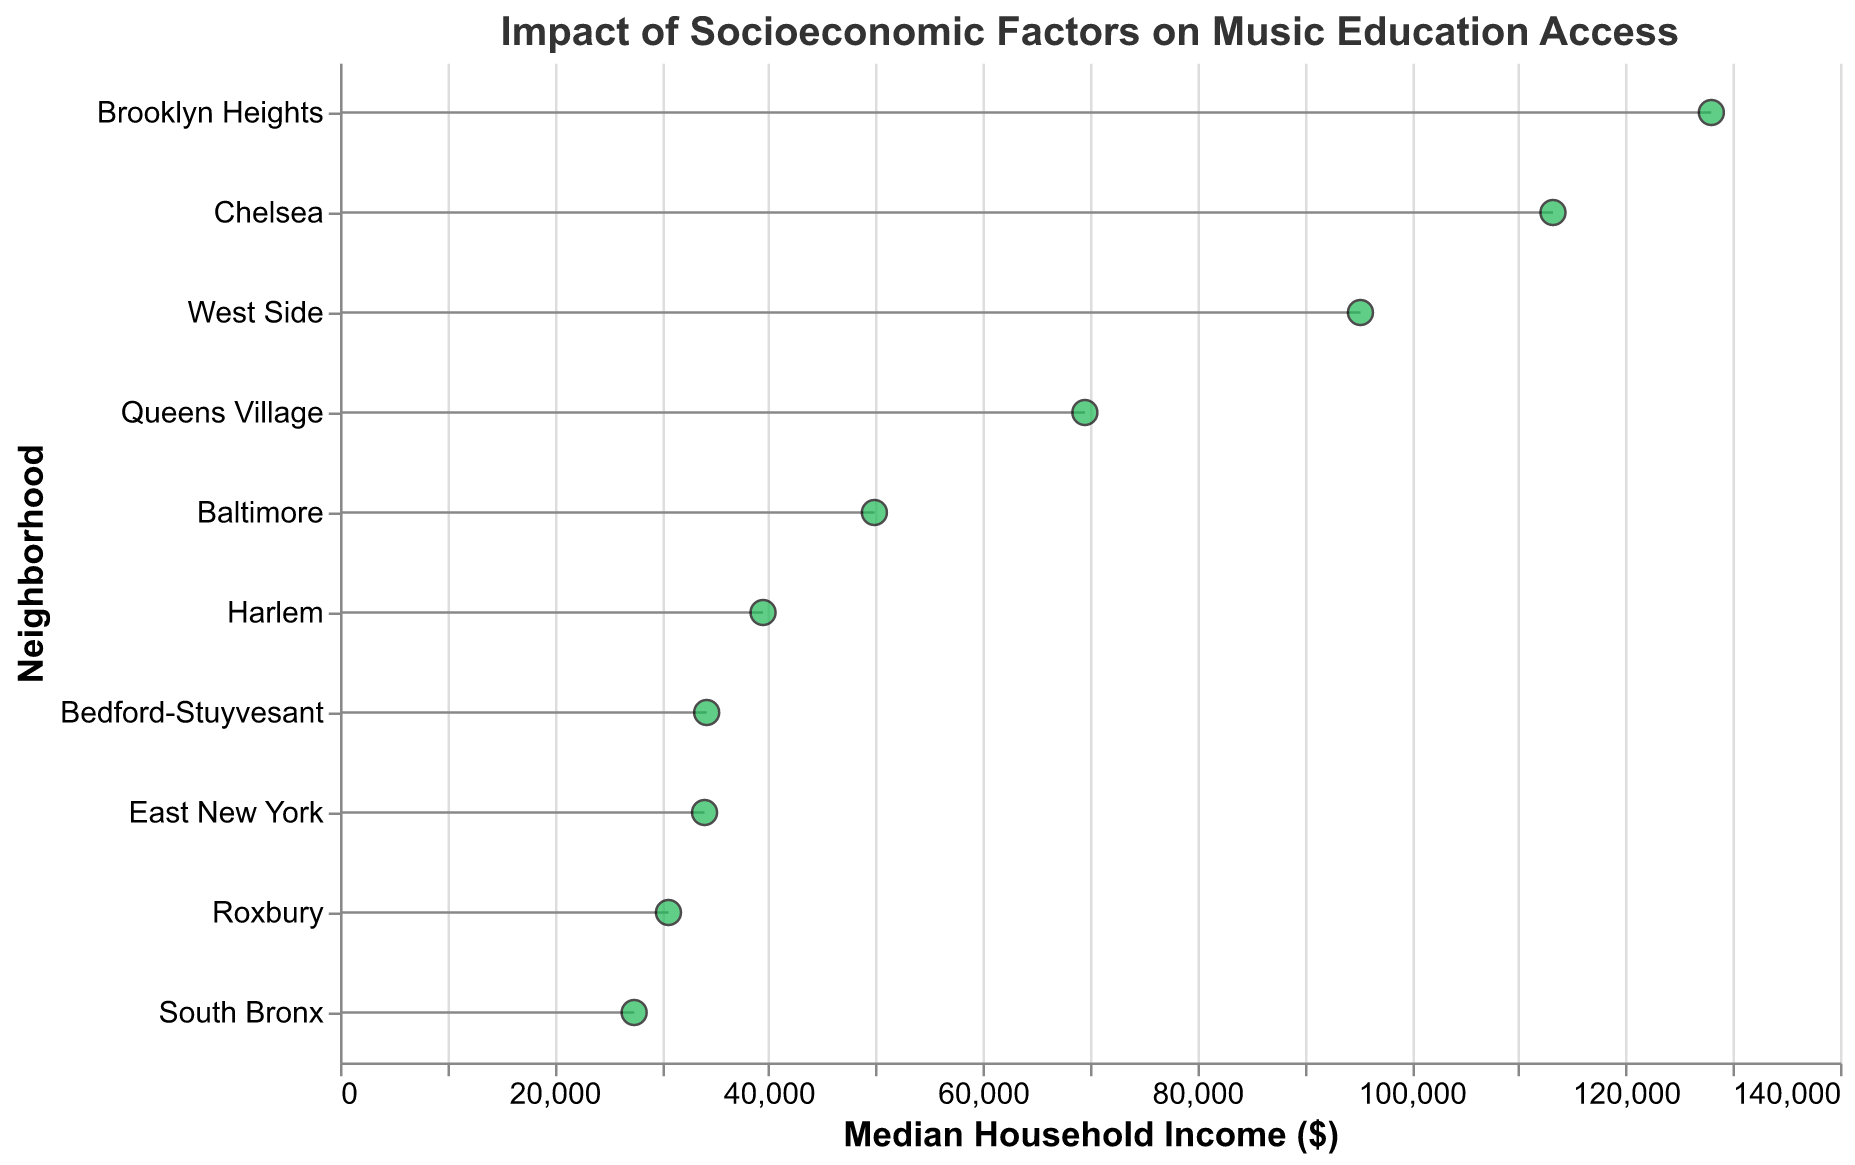What's the neighborhood with the highest median household income? The figure shows the median household incomes along the x-axis, and the highest data point is Brooklyn Heights with $127,994.
Answer: Brooklyn Heights Which neighborhood has the highest percentage of students receiving financial aid? By checking the tooltip information, South Bronx has the highest percentage of students receiving financial aid at 80%.
Answer: South Bronx How many music schools are present in Brooklyn Heights? According to the tooltip data, Brooklyn Heights has 8 music schools.
Answer: 8 What is the total number of music schools in neighborhoods with median household incomes below $40,000? Harlem has 5 schools, Bedford-Stuyvesant has 3, South Bronx has 2, Roxbury has 4, and East New York has 3. Total = 5 + 3 + 2 + 4 + 3 = 17 schools.
Answer: 17 Which neighborhoods have a median household income between $60,000 and $100,000? Queens Village at $69,523, West Side at $95,243, and Baltimore at $49,877 (excluding this step as 49,877 < 60,000). So, those within $60k-$100k are Queens Village and West Side.
Answer: Queens Village, West Side Which neighborhood has more music schools: South Bronx or Bedford-Stuyvesant? South Bronx has 2 music schools, while Bedford-Stuyvesant has 3 music schools.
Answer: Bedford-Stuyvesant What is the average percentage of students receiving financial aid in Roxbury and East New York? Roxbury is at 65%, and East New York is at 55%. The average is (65 + 55) / 2 = 60%.
Answer: 60% Which neighborhood has the lowest number of registered students? The tooltip for South Bronx shows that it has the lowest number of registered students, which is 75.
Answer: South Bronx What is the difference in the median household income between Chelsea and Brooklyn Heights? Chelsea has a median income of $113,212, while Brooklyn Heights has $127,994. The difference is $127,994 - $113,212 = $14,782.
Answer: $14,782 